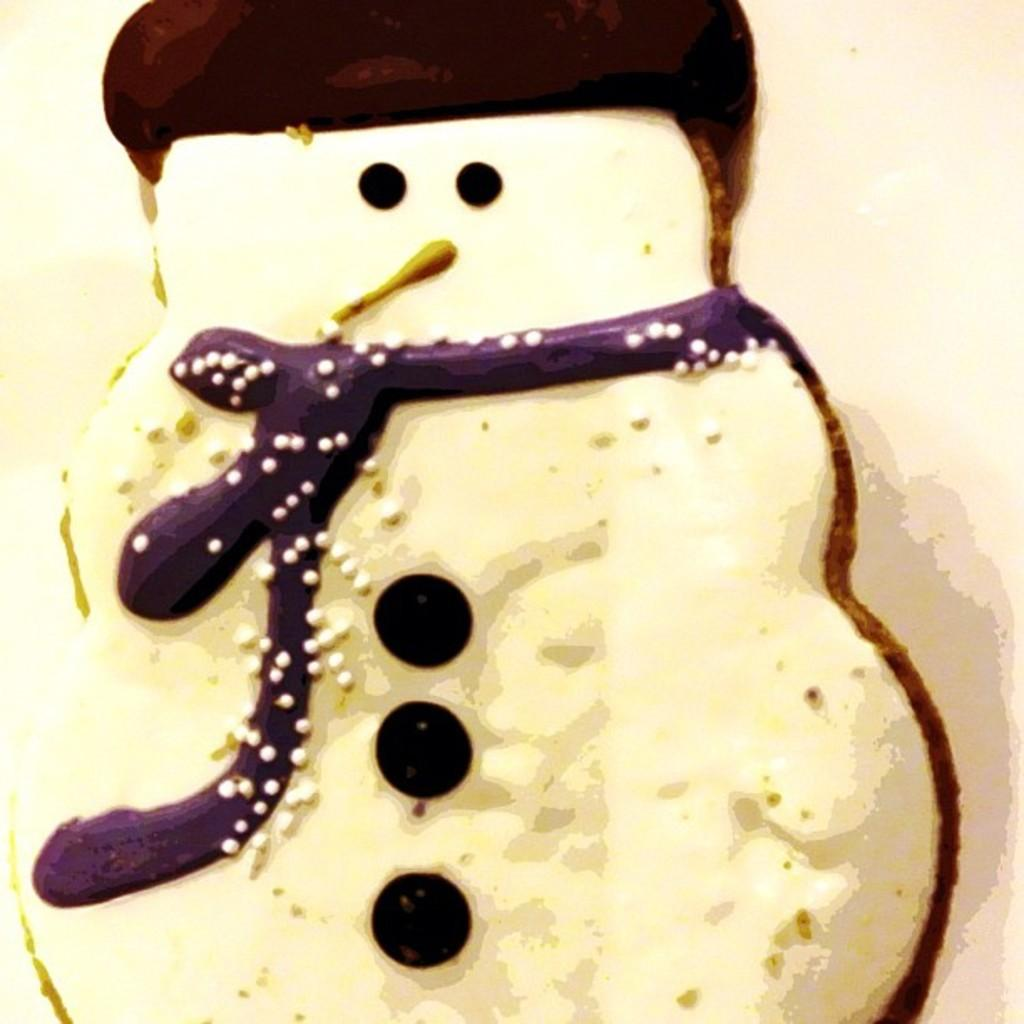What type of cookie is depicted in the image? There is a cookie in the shape of a snowman. Can you describe the design of the cookie? The cookie is in the shape of a snowman. What type of respect can be seen being shown to the seashore in the image? There is no seashore present in the image, so it is not possible to determine what type of respect might be shown to it. 